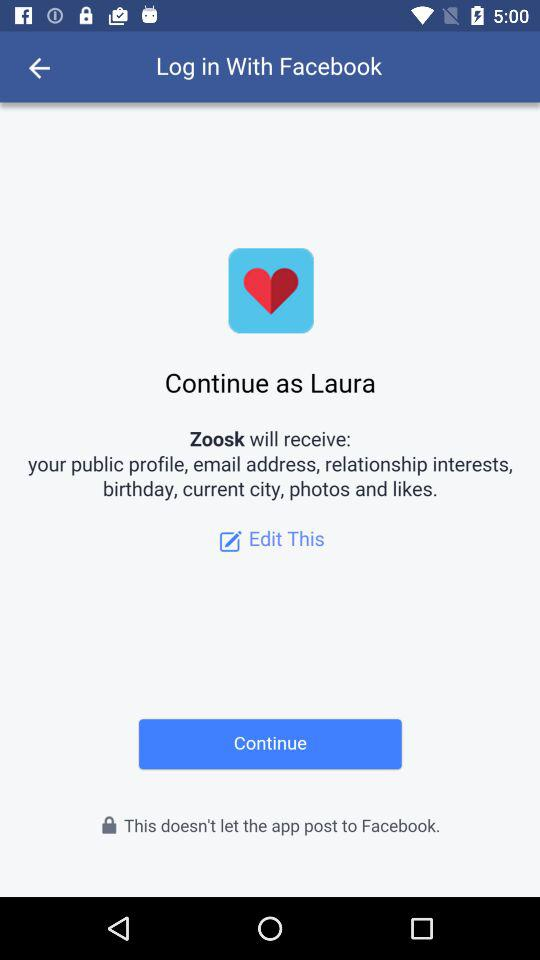What is the name of the user? The name of the user is Laura. 